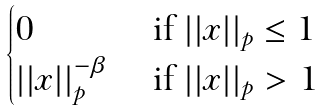Convert formula to latex. <formula><loc_0><loc_0><loc_500><loc_500>\begin{cases} 0 & \text { if } | | x | | _ { p } \leq 1 \\ | | x | | _ { p } ^ { - \beta } & \text { if } | | x | | _ { p } > 1 \end{cases}</formula> 